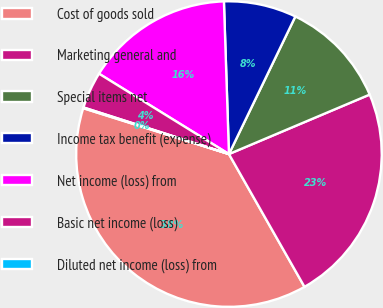Convert chart. <chart><loc_0><loc_0><loc_500><loc_500><pie_chart><fcel>Cost of goods sold<fcel>Marketing general and<fcel>Special items net<fcel>Income tax benefit (expense)<fcel>Net income (loss) from<fcel>Basic net income (loss)<fcel>Diluted net income (loss) from<nl><fcel>38.09%<fcel>23.13%<fcel>11.48%<fcel>7.68%<fcel>15.66%<fcel>3.88%<fcel>0.08%<nl></chart> 